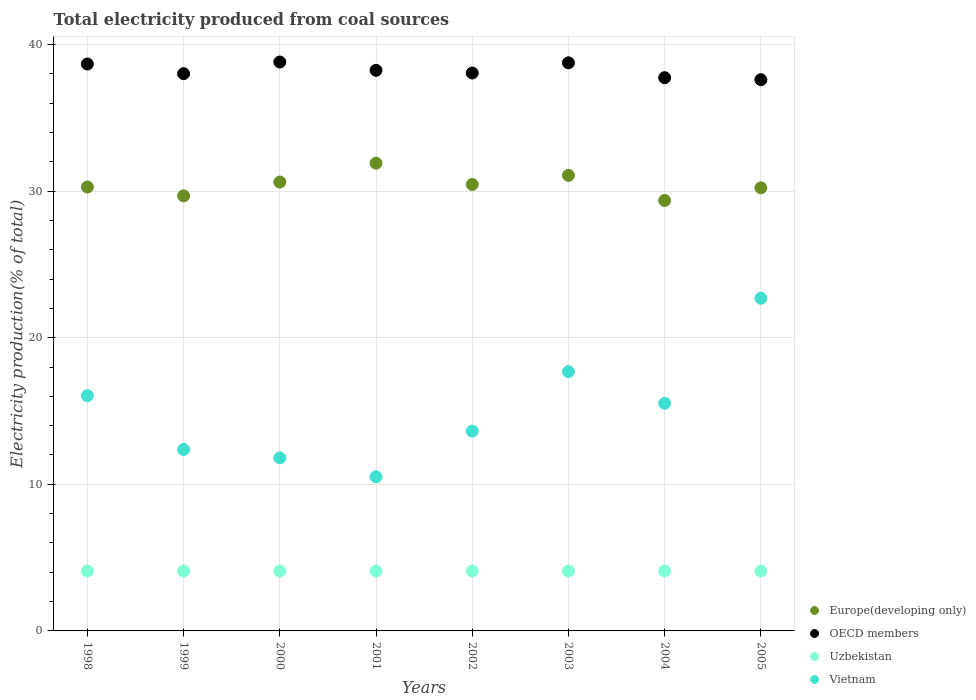What is the total electricity produced in Vietnam in 1999?
Your response must be concise. 12.37. Across all years, what is the maximum total electricity produced in OECD members?
Offer a very short reply. 38.8. Across all years, what is the minimum total electricity produced in Vietnam?
Your answer should be very brief. 10.51. In which year was the total electricity produced in Europe(developing only) maximum?
Your response must be concise. 2001. What is the total total electricity produced in Europe(developing only) in the graph?
Your answer should be compact. 243.56. What is the difference between the total electricity produced in Uzbekistan in 2001 and that in 2003?
Offer a terse response. -0. What is the difference between the total electricity produced in OECD members in 1999 and the total electricity produced in Vietnam in 2000?
Provide a succinct answer. 26.2. What is the average total electricity produced in OECD members per year?
Your answer should be very brief. 38.23. In the year 2000, what is the difference between the total electricity produced in Europe(developing only) and total electricity produced in Vietnam?
Your answer should be very brief. 18.81. In how many years, is the total electricity produced in Uzbekistan greater than 10 %?
Provide a short and direct response. 0. What is the ratio of the total electricity produced in OECD members in 1999 to that in 2003?
Give a very brief answer. 0.98. Is the total electricity produced in Vietnam in 1999 less than that in 2000?
Offer a very short reply. No. Is the difference between the total electricity produced in Europe(developing only) in 1998 and 2005 greater than the difference between the total electricity produced in Vietnam in 1998 and 2005?
Make the answer very short. Yes. What is the difference between the highest and the second highest total electricity produced in Europe(developing only)?
Offer a terse response. 0.83. What is the difference between the highest and the lowest total electricity produced in Uzbekistan?
Offer a very short reply. 0. In how many years, is the total electricity produced in OECD members greater than the average total electricity produced in OECD members taken over all years?
Provide a succinct answer. 4. Is it the case that in every year, the sum of the total electricity produced in OECD members and total electricity produced in Europe(developing only)  is greater than the sum of total electricity produced in Vietnam and total electricity produced in Uzbekistan?
Offer a terse response. Yes. Is it the case that in every year, the sum of the total electricity produced in Vietnam and total electricity produced in OECD members  is greater than the total electricity produced in Europe(developing only)?
Offer a very short reply. Yes. Is the total electricity produced in Europe(developing only) strictly less than the total electricity produced in Uzbekistan over the years?
Keep it short and to the point. No. What is the difference between two consecutive major ticks on the Y-axis?
Provide a short and direct response. 10. Are the values on the major ticks of Y-axis written in scientific E-notation?
Ensure brevity in your answer.  No. Does the graph contain any zero values?
Ensure brevity in your answer.  No. How many legend labels are there?
Ensure brevity in your answer.  4. What is the title of the graph?
Give a very brief answer. Total electricity produced from coal sources. What is the label or title of the X-axis?
Provide a short and direct response. Years. What is the Electricity production(% of total) in Europe(developing only) in 1998?
Your answer should be very brief. 30.28. What is the Electricity production(% of total) in OECD members in 1998?
Keep it short and to the point. 38.66. What is the Electricity production(% of total) of Uzbekistan in 1998?
Offer a terse response. 4.08. What is the Electricity production(% of total) of Vietnam in 1998?
Make the answer very short. 16.05. What is the Electricity production(% of total) of Europe(developing only) in 1999?
Your answer should be compact. 29.67. What is the Electricity production(% of total) of OECD members in 1999?
Provide a succinct answer. 38.01. What is the Electricity production(% of total) in Uzbekistan in 1999?
Provide a succinct answer. 4.09. What is the Electricity production(% of total) in Vietnam in 1999?
Keep it short and to the point. 12.37. What is the Electricity production(% of total) of Europe(developing only) in 2000?
Make the answer very short. 30.61. What is the Electricity production(% of total) of OECD members in 2000?
Your answer should be compact. 38.8. What is the Electricity production(% of total) of Uzbekistan in 2000?
Provide a succinct answer. 4.09. What is the Electricity production(% of total) of Vietnam in 2000?
Offer a very short reply. 11.8. What is the Electricity production(% of total) of Europe(developing only) in 2001?
Keep it short and to the point. 31.9. What is the Electricity production(% of total) of OECD members in 2001?
Your answer should be very brief. 38.23. What is the Electricity production(% of total) of Uzbekistan in 2001?
Offer a very short reply. 4.08. What is the Electricity production(% of total) in Vietnam in 2001?
Ensure brevity in your answer.  10.51. What is the Electricity production(% of total) of Europe(developing only) in 2002?
Your answer should be very brief. 30.45. What is the Electricity production(% of total) of OECD members in 2002?
Give a very brief answer. 38.05. What is the Electricity production(% of total) of Uzbekistan in 2002?
Offer a very short reply. 4.08. What is the Electricity production(% of total) in Vietnam in 2002?
Your answer should be compact. 13.63. What is the Electricity production(% of total) in Europe(developing only) in 2003?
Give a very brief answer. 31.07. What is the Electricity production(% of total) in OECD members in 2003?
Offer a very short reply. 38.75. What is the Electricity production(% of total) of Uzbekistan in 2003?
Your response must be concise. 4.09. What is the Electricity production(% of total) in Vietnam in 2003?
Offer a very short reply. 17.68. What is the Electricity production(% of total) of Europe(developing only) in 2004?
Offer a very short reply. 29.36. What is the Electricity production(% of total) of OECD members in 2004?
Make the answer very short. 37.73. What is the Electricity production(% of total) of Uzbekistan in 2004?
Your answer should be very brief. 4.09. What is the Electricity production(% of total) of Vietnam in 2004?
Your answer should be compact. 15.52. What is the Electricity production(% of total) of Europe(developing only) in 2005?
Your answer should be compact. 30.22. What is the Electricity production(% of total) of OECD members in 2005?
Provide a short and direct response. 37.6. What is the Electricity production(% of total) of Uzbekistan in 2005?
Your answer should be compact. 4.08. What is the Electricity production(% of total) in Vietnam in 2005?
Give a very brief answer. 22.69. Across all years, what is the maximum Electricity production(% of total) of Europe(developing only)?
Provide a succinct answer. 31.9. Across all years, what is the maximum Electricity production(% of total) of OECD members?
Give a very brief answer. 38.8. Across all years, what is the maximum Electricity production(% of total) in Uzbekistan?
Your answer should be compact. 4.09. Across all years, what is the maximum Electricity production(% of total) of Vietnam?
Your answer should be very brief. 22.69. Across all years, what is the minimum Electricity production(% of total) in Europe(developing only)?
Keep it short and to the point. 29.36. Across all years, what is the minimum Electricity production(% of total) of OECD members?
Give a very brief answer. 37.6. Across all years, what is the minimum Electricity production(% of total) of Uzbekistan?
Provide a succinct answer. 4.08. Across all years, what is the minimum Electricity production(% of total) of Vietnam?
Your answer should be compact. 10.51. What is the total Electricity production(% of total) in Europe(developing only) in the graph?
Your response must be concise. 243.56. What is the total Electricity production(% of total) of OECD members in the graph?
Provide a succinct answer. 305.83. What is the total Electricity production(% of total) in Uzbekistan in the graph?
Ensure brevity in your answer.  32.68. What is the total Electricity production(% of total) of Vietnam in the graph?
Ensure brevity in your answer.  120.26. What is the difference between the Electricity production(% of total) of Europe(developing only) in 1998 and that in 1999?
Give a very brief answer. 0.61. What is the difference between the Electricity production(% of total) in OECD members in 1998 and that in 1999?
Provide a succinct answer. 0.66. What is the difference between the Electricity production(% of total) of Uzbekistan in 1998 and that in 1999?
Your answer should be very brief. -0. What is the difference between the Electricity production(% of total) of Vietnam in 1998 and that in 1999?
Your response must be concise. 3.67. What is the difference between the Electricity production(% of total) of Europe(developing only) in 1998 and that in 2000?
Provide a succinct answer. -0.34. What is the difference between the Electricity production(% of total) in OECD members in 1998 and that in 2000?
Provide a short and direct response. -0.14. What is the difference between the Electricity production(% of total) of Uzbekistan in 1998 and that in 2000?
Make the answer very short. -0. What is the difference between the Electricity production(% of total) of Vietnam in 1998 and that in 2000?
Your answer should be compact. 4.24. What is the difference between the Electricity production(% of total) in Europe(developing only) in 1998 and that in 2001?
Provide a short and direct response. -1.63. What is the difference between the Electricity production(% of total) in OECD members in 1998 and that in 2001?
Make the answer very short. 0.43. What is the difference between the Electricity production(% of total) in Uzbekistan in 1998 and that in 2001?
Provide a succinct answer. 0. What is the difference between the Electricity production(% of total) in Vietnam in 1998 and that in 2001?
Offer a terse response. 5.53. What is the difference between the Electricity production(% of total) of Europe(developing only) in 1998 and that in 2002?
Keep it short and to the point. -0.17. What is the difference between the Electricity production(% of total) in OECD members in 1998 and that in 2002?
Your answer should be compact. 0.61. What is the difference between the Electricity production(% of total) of Uzbekistan in 1998 and that in 2002?
Your answer should be compact. 0. What is the difference between the Electricity production(% of total) of Vietnam in 1998 and that in 2002?
Provide a short and direct response. 2.42. What is the difference between the Electricity production(% of total) in Europe(developing only) in 1998 and that in 2003?
Keep it short and to the point. -0.8. What is the difference between the Electricity production(% of total) in OECD members in 1998 and that in 2003?
Ensure brevity in your answer.  -0.08. What is the difference between the Electricity production(% of total) in Uzbekistan in 1998 and that in 2003?
Give a very brief answer. -0. What is the difference between the Electricity production(% of total) in Vietnam in 1998 and that in 2003?
Offer a terse response. -1.64. What is the difference between the Electricity production(% of total) in Europe(developing only) in 1998 and that in 2004?
Your answer should be very brief. 0.92. What is the difference between the Electricity production(% of total) in OECD members in 1998 and that in 2004?
Your answer should be compact. 0.93. What is the difference between the Electricity production(% of total) of Uzbekistan in 1998 and that in 2004?
Provide a short and direct response. -0. What is the difference between the Electricity production(% of total) in Vietnam in 1998 and that in 2004?
Provide a short and direct response. 0.52. What is the difference between the Electricity production(% of total) of Europe(developing only) in 1998 and that in 2005?
Keep it short and to the point. 0.06. What is the difference between the Electricity production(% of total) in OECD members in 1998 and that in 2005?
Make the answer very short. 1.07. What is the difference between the Electricity production(% of total) of Uzbekistan in 1998 and that in 2005?
Your answer should be compact. 0. What is the difference between the Electricity production(% of total) of Vietnam in 1998 and that in 2005?
Your answer should be compact. -6.65. What is the difference between the Electricity production(% of total) of Europe(developing only) in 1999 and that in 2000?
Your answer should be compact. -0.94. What is the difference between the Electricity production(% of total) in OECD members in 1999 and that in 2000?
Offer a terse response. -0.79. What is the difference between the Electricity production(% of total) of Uzbekistan in 1999 and that in 2000?
Offer a very short reply. -0. What is the difference between the Electricity production(% of total) of Vietnam in 1999 and that in 2000?
Give a very brief answer. 0.57. What is the difference between the Electricity production(% of total) of Europe(developing only) in 1999 and that in 2001?
Your answer should be very brief. -2.23. What is the difference between the Electricity production(% of total) of OECD members in 1999 and that in 2001?
Make the answer very short. -0.23. What is the difference between the Electricity production(% of total) in Uzbekistan in 1999 and that in 2001?
Provide a succinct answer. 0. What is the difference between the Electricity production(% of total) in Vietnam in 1999 and that in 2001?
Keep it short and to the point. 1.86. What is the difference between the Electricity production(% of total) of Europe(developing only) in 1999 and that in 2002?
Provide a succinct answer. -0.78. What is the difference between the Electricity production(% of total) in OECD members in 1999 and that in 2002?
Your answer should be compact. -0.04. What is the difference between the Electricity production(% of total) of Uzbekistan in 1999 and that in 2002?
Ensure brevity in your answer.  0. What is the difference between the Electricity production(% of total) of Vietnam in 1999 and that in 2002?
Offer a terse response. -1.25. What is the difference between the Electricity production(% of total) of Europe(developing only) in 1999 and that in 2003?
Keep it short and to the point. -1.4. What is the difference between the Electricity production(% of total) of OECD members in 1999 and that in 2003?
Your answer should be compact. -0.74. What is the difference between the Electricity production(% of total) of Uzbekistan in 1999 and that in 2003?
Make the answer very short. 0. What is the difference between the Electricity production(% of total) of Vietnam in 1999 and that in 2003?
Make the answer very short. -5.31. What is the difference between the Electricity production(% of total) of Europe(developing only) in 1999 and that in 2004?
Give a very brief answer. 0.31. What is the difference between the Electricity production(% of total) of OECD members in 1999 and that in 2004?
Your response must be concise. 0.28. What is the difference between the Electricity production(% of total) in Uzbekistan in 1999 and that in 2004?
Your answer should be compact. 0. What is the difference between the Electricity production(% of total) in Vietnam in 1999 and that in 2004?
Your answer should be compact. -3.15. What is the difference between the Electricity production(% of total) in Europe(developing only) in 1999 and that in 2005?
Your response must be concise. -0.55. What is the difference between the Electricity production(% of total) of OECD members in 1999 and that in 2005?
Provide a short and direct response. 0.41. What is the difference between the Electricity production(% of total) in Uzbekistan in 1999 and that in 2005?
Provide a short and direct response. 0. What is the difference between the Electricity production(% of total) of Vietnam in 1999 and that in 2005?
Your response must be concise. -10.32. What is the difference between the Electricity production(% of total) of Europe(developing only) in 2000 and that in 2001?
Your answer should be very brief. -1.29. What is the difference between the Electricity production(% of total) of OECD members in 2000 and that in 2001?
Make the answer very short. 0.56. What is the difference between the Electricity production(% of total) in Uzbekistan in 2000 and that in 2001?
Provide a succinct answer. 0. What is the difference between the Electricity production(% of total) of Vietnam in 2000 and that in 2001?
Provide a short and direct response. 1.29. What is the difference between the Electricity production(% of total) in Europe(developing only) in 2000 and that in 2002?
Your answer should be compact. 0.16. What is the difference between the Electricity production(% of total) of OECD members in 2000 and that in 2002?
Provide a short and direct response. 0.75. What is the difference between the Electricity production(% of total) of Uzbekistan in 2000 and that in 2002?
Keep it short and to the point. 0. What is the difference between the Electricity production(% of total) of Vietnam in 2000 and that in 2002?
Your answer should be compact. -1.82. What is the difference between the Electricity production(% of total) in Europe(developing only) in 2000 and that in 2003?
Keep it short and to the point. -0.46. What is the difference between the Electricity production(% of total) in OECD members in 2000 and that in 2003?
Your response must be concise. 0.05. What is the difference between the Electricity production(% of total) in Uzbekistan in 2000 and that in 2003?
Provide a succinct answer. 0. What is the difference between the Electricity production(% of total) of Vietnam in 2000 and that in 2003?
Make the answer very short. -5.88. What is the difference between the Electricity production(% of total) of Europe(developing only) in 2000 and that in 2004?
Offer a very short reply. 1.25. What is the difference between the Electricity production(% of total) in OECD members in 2000 and that in 2004?
Offer a terse response. 1.07. What is the difference between the Electricity production(% of total) of Uzbekistan in 2000 and that in 2004?
Your answer should be compact. 0. What is the difference between the Electricity production(% of total) in Vietnam in 2000 and that in 2004?
Give a very brief answer. -3.72. What is the difference between the Electricity production(% of total) of Europe(developing only) in 2000 and that in 2005?
Your response must be concise. 0.39. What is the difference between the Electricity production(% of total) of OECD members in 2000 and that in 2005?
Your response must be concise. 1.2. What is the difference between the Electricity production(% of total) of Uzbekistan in 2000 and that in 2005?
Your answer should be very brief. 0. What is the difference between the Electricity production(% of total) in Vietnam in 2000 and that in 2005?
Make the answer very short. -10.89. What is the difference between the Electricity production(% of total) in Europe(developing only) in 2001 and that in 2002?
Your answer should be compact. 1.45. What is the difference between the Electricity production(% of total) in OECD members in 2001 and that in 2002?
Your answer should be very brief. 0.18. What is the difference between the Electricity production(% of total) of Uzbekistan in 2001 and that in 2002?
Your answer should be compact. -0. What is the difference between the Electricity production(% of total) in Vietnam in 2001 and that in 2002?
Give a very brief answer. -3.11. What is the difference between the Electricity production(% of total) of Europe(developing only) in 2001 and that in 2003?
Offer a terse response. 0.83. What is the difference between the Electricity production(% of total) of OECD members in 2001 and that in 2003?
Provide a short and direct response. -0.51. What is the difference between the Electricity production(% of total) of Uzbekistan in 2001 and that in 2003?
Keep it short and to the point. -0. What is the difference between the Electricity production(% of total) in Vietnam in 2001 and that in 2003?
Give a very brief answer. -7.17. What is the difference between the Electricity production(% of total) of Europe(developing only) in 2001 and that in 2004?
Keep it short and to the point. 2.54. What is the difference between the Electricity production(% of total) of OECD members in 2001 and that in 2004?
Your answer should be very brief. 0.5. What is the difference between the Electricity production(% of total) in Uzbekistan in 2001 and that in 2004?
Provide a succinct answer. -0. What is the difference between the Electricity production(% of total) of Vietnam in 2001 and that in 2004?
Ensure brevity in your answer.  -5.01. What is the difference between the Electricity production(% of total) of Europe(developing only) in 2001 and that in 2005?
Your response must be concise. 1.68. What is the difference between the Electricity production(% of total) in OECD members in 2001 and that in 2005?
Offer a very short reply. 0.64. What is the difference between the Electricity production(% of total) of Uzbekistan in 2001 and that in 2005?
Your response must be concise. 0. What is the difference between the Electricity production(% of total) in Vietnam in 2001 and that in 2005?
Offer a terse response. -12.18. What is the difference between the Electricity production(% of total) in Europe(developing only) in 2002 and that in 2003?
Make the answer very short. -0.62. What is the difference between the Electricity production(% of total) in OECD members in 2002 and that in 2003?
Make the answer very short. -0.7. What is the difference between the Electricity production(% of total) of Uzbekistan in 2002 and that in 2003?
Your response must be concise. -0. What is the difference between the Electricity production(% of total) of Vietnam in 2002 and that in 2003?
Your answer should be compact. -4.06. What is the difference between the Electricity production(% of total) in Europe(developing only) in 2002 and that in 2004?
Give a very brief answer. 1.09. What is the difference between the Electricity production(% of total) in OECD members in 2002 and that in 2004?
Ensure brevity in your answer.  0.32. What is the difference between the Electricity production(% of total) of Uzbekistan in 2002 and that in 2004?
Ensure brevity in your answer.  -0. What is the difference between the Electricity production(% of total) in Vietnam in 2002 and that in 2004?
Ensure brevity in your answer.  -1.9. What is the difference between the Electricity production(% of total) of Europe(developing only) in 2002 and that in 2005?
Give a very brief answer. 0.23. What is the difference between the Electricity production(% of total) in OECD members in 2002 and that in 2005?
Your response must be concise. 0.45. What is the difference between the Electricity production(% of total) of Uzbekistan in 2002 and that in 2005?
Your response must be concise. 0. What is the difference between the Electricity production(% of total) in Vietnam in 2002 and that in 2005?
Make the answer very short. -9.06. What is the difference between the Electricity production(% of total) in Europe(developing only) in 2003 and that in 2004?
Make the answer very short. 1.71. What is the difference between the Electricity production(% of total) of OECD members in 2003 and that in 2004?
Your answer should be compact. 1.02. What is the difference between the Electricity production(% of total) of Uzbekistan in 2003 and that in 2004?
Your answer should be compact. -0. What is the difference between the Electricity production(% of total) of Vietnam in 2003 and that in 2004?
Provide a succinct answer. 2.16. What is the difference between the Electricity production(% of total) of Europe(developing only) in 2003 and that in 2005?
Ensure brevity in your answer.  0.85. What is the difference between the Electricity production(% of total) of OECD members in 2003 and that in 2005?
Provide a short and direct response. 1.15. What is the difference between the Electricity production(% of total) in Uzbekistan in 2003 and that in 2005?
Provide a succinct answer. 0. What is the difference between the Electricity production(% of total) in Vietnam in 2003 and that in 2005?
Give a very brief answer. -5.01. What is the difference between the Electricity production(% of total) of Europe(developing only) in 2004 and that in 2005?
Provide a short and direct response. -0.86. What is the difference between the Electricity production(% of total) of OECD members in 2004 and that in 2005?
Your response must be concise. 0.13. What is the difference between the Electricity production(% of total) in Uzbekistan in 2004 and that in 2005?
Ensure brevity in your answer.  0. What is the difference between the Electricity production(% of total) of Vietnam in 2004 and that in 2005?
Offer a very short reply. -7.17. What is the difference between the Electricity production(% of total) of Europe(developing only) in 1998 and the Electricity production(% of total) of OECD members in 1999?
Your answer should be compact. -7.73. What is the difference between the Electricity production(% of total) in Europe(developing only) in 1998 and the Electricity production(% of total) in Uzbekistan in 1999?
Make the answer very short. 26.19. What is the difference between the Electricity production(% of total) of Europe(developing only) in 1998 and the Electricity production(% of total) of Vietnam in 1999?
Your response must be concise. 17.9. What is the difference between the Electricity production(% of total) in OECD members in 1998 and the Electricity production(% of total) in Uzbekistan in 1999?
Your answer should be compact. 34.58. What is the difference between the Electricity production(% of total) of OECD members in 1998 and the Electricity production(% of total) of Vietnam in 1999?
Ensure brevity in your answer.  26.29. What is the difference between the Electricity production(% of total) of Uzbekistan in 1998 and the Electricity production(% of total) of Vietnam in 1999?
Give a very brief answer. -8.29. What is the difference between the Electricity production(% of total) in Europe(developing only) in 1998 and the Electricity production(% of total) in OECD members in 2000?
Provide a short and direct response. -8.52. What is the difference between the Electricity production(% of total) in Europe(developing only) in 1998 and the Electricity production(% of total) in Uzbekistan in 2000?
Offer a terse response. 26.19. What is the difference between the Electricity production(% of total) of Europe(developing only) in 1998 and the Electricity production(% of total) of Vietnam in 2000?
Make the answer very short. 18.47. What is the difference between the Electricity production(% of total) of OECD members in 1998 and the Electricity production(% of total) of Uzbekistan in 2000?
Your response must be concise. 34.58. What is the difference between the Electricity production(% of total) in OECD members in 1998 and the Electricity production(% of total) in Vietnam in 2000?
Offer a very short reply. 26.86. What is the difference between the Electricity production(% of total) in Uzbekistan in 1998 and the Electricity production(% of total) in Vietnam in 2000?
Offer a terse response. -7.72. What is the difference between the Electricity production(% of total) in Europe(developing only) in 1998 and the Electricity production(% of total) in OECD members in 2001?
Offer a very short reply. -7.96. What is the difference between the Electricity production(% of total) of Europe(developing only) in 1998 and the Electricity production(% of total) of Uzbekistan in 2001?
Give a very brief answer. 26.19. What is the difference between the Electricity production(% of total) in Europe(developing only) in 1998 and the Electricity production(% of total) in Vietnam in 2001?
Give a very brief answer. 19.76. What is the difference between the Electricity production(% of total) of OECD members in 1998 and the Electricity production(% of total) of Uzbekistan in 2001?
Ensure brevity in your answer.  34.58. What is the difference between the Electricity production(% of total) of OECD members in 1998 and the Electricity production(% of total) of Vietnam in 2001?
Ensure brevity in your answer.  28.15. What is the difference between the Electricity production(% of total) in Uzbekistan in 1998 and the Electricity production(% of total) in Vietnam in 2001?
Provide a short and direct response. -6.43. What is the difference between the Electricity production(% of total) of Europe(developing only) in 1998 and the Electricity production(% of total) of OECD members in 2002?
Provide a succinct answer. -7.77. What is the difference between the Electricity production(% of total) of Europe(developing only) in 1998 and the Electricity production(% of total) of Uzbekistan in 2002?
Ensure brevity in your answer.  26.19. What is the difference between the Electricity production(% of total) in Europe(developing only) in 1998 and the Electricity production(% of total) in Vietnam in 2002?
Make the answer very short. 16.65. What is the difference between the Electricity production(% of total) of OECD members in 1998 and the Electricity production(% of total) of Uzbekistan in 2002?
Provide a succinct answer. 34.58. What is the difference between the Electricity production(% of total) in OECD members in 1998 and the Electricity production(% of total) in Vietnam in 2002?
Give a very brief answer. 25.04. What is the difference between the Electricity production(% of total) in Uzbekistan in 1998 and the Electricity production(% of total) in Vietnam in 2002?
Provide a succinct answer. -9.54. What is the difference between the Electricity production(% of total) in Europe(developing only) in 1998 and the Electricity production(% of total) in OECD members in 2003?
Offer a terse response. -8.47. What is the difference between the Electricity production(% of total) of Europe(developing only) in 1998 and the Electricity production(% of total) of Uzbekistan in 2003?
Provide a short and direct response. 26.19. What is the difference between the Electricity production(% of total) in Europe(developing only) in 1998 and the Electricity production(% of total) in Vietnam in 2003?
Provide a short and direct response. 12.59. What is the difference between the Electricity production(% of total) in OECD members in 1998 and the Electricity production(% of total) in Uzbekistan in 2003?
Your answer should be very brief. 34.58. What is the difference between the Electricity production(% of total) in OECD members in 1998 and the Electricity production(% of total) in Vietnam in 2003?
Your response must be concise. 20.98. What is the difference between the Electricity production(% of total) in Uzbekistan in 1998 and the Electricity production(% of total) in Vietnam in 2003?
Offer a very short reply. -13.6. What is the difference between the Electricity production(% of total) of Europe(developing only) in 1998 and the Electricity production(% of total) of OECD members in 2004?
Provide a short and direct response. -7.45. What is the difference between the Electricity production(% of total) in Europe(developing only) in 1998 and the Electricity production(% of total) in Uzbekistan in 2004?
Keep it short and to the point. 26.19. What is the difference between the Electricity production(% of total) of Europe(developing only) in 1998 and the Electricity production(% of total) of Vietnam in 2004?
Your response must be concise. 14.75. What is the difference between the Electricity production(% of total) of OECD members in 1998 and the Electricity production(% of total) of Uzbekistan in 2004?
Offer a very short reply. 34.58. What is the difference between the Electricity production(% of total) of OECD members in 1998 and the Electricity production(% of total) of Vietnam in 2004?
Make the answer very short. 23.14. What is the difference between the Electricity production(% of total) of Uzbekistan in 1998 and the Electricity production(% of total) of Vietnam in 2004?
Offer a terse response. -11.44. What is the difference between the Electricity production(% of total) of Europe(developing only) in 1998 and the Electricity production(% of total) of OECD members in 2005?
Provide a succinct answer. -7.32. What is the difference between the Electricity production(% of total) in Europe(developing only) in 1998 and the Electricity production(% of total) in Uzbekistan in 2005?
Your response must be concise. 26.19. What is the difference between the Electricity production(% of total) of Europe(developing only) in 1998 and the Electricity production(% of total) of Vietnam in 2005?
Your answer should be very brief. 7.58. What is the difference between the Electricity production(% of total) in OECD members in 1998 and the Electricity production(% of total) in Uzbekistan in 2005?
Offer a terse response. 34.58. What is the difference between the Electricity production(% of total) in OECD members in 1998 and the Electricity production(% of total) in Vietnam in 2005?
Your response must be concise. 15.97. What is the difference between the Electricity production(% of total) in Uzbekistan in 1998 and the Electricity production(% of total) in Vietnam in 2005?
Your answer should be very brief. -18.61. What is the difference between the Electricity production(% of total) of Europe(developing only) in 1999 and the Electricity production(% of total) of OECD members in 2000?
Offer a terse response. -9.13. What is the difference between the Electricity production(% of total) of Europe(developing only) in 1999 and the Electricity production(% of total) of Uzbekistan in 2000?
Ensure brevity in your answer.  25.58. What is the difference between the Electricity production(% of total) of Europe(developing only) in 1999 and the Electricity production(% of total) of Vietnam in 2000?
Offer a very short reply. 17.87. What is the difference between the Electricity production(% of total) of OECD members in 1999 and the Electricity production(% of total) of Uzbekistan in 2000?
Offer a very short reply. 33.92. What is the difference between the Electricity production(% of total) in OECD members in 1999 and the Electricity production(% of total) in Vietnam in 2000?
Your answer should be compact. 26.2. What is the difference between the Electricity production(% of total) in Uzbekistan in 1999 and the Electricity production(% of total) in Vietnam in 2000?
Give a very brief answer. -7.72. What is the difference between the Electricity production(% of total) of Europe(developing only) in 1999 and the Electricity production(% of total) of OECD members in 2001?
Provide a short and direct response. -8.56. What is the difference between the Electricity production(% of total) of Europe(developing only) in 1999 and the Electricity production(% of total) of Uzbekistan in 2001?
Ensure brevity in your answer.  25.59. What is the difference between the Electricity production(% of total) in Europe(developing only) in 1999 and the Electricity production(% of total) in Vietnam in 2001?
Your response must be concise. 19.16. What is the difference between the Electricity production(% of total) in OECD members in 1999 and the Electricity production(% of total) in Uzbekistan in 2001?
Keep it short and to the point. 33.92. What is the difference between the Electricity production(% of total) in OECD members in 1999 and the Electricity production(% of total) in Vietnam in 2001?
Your response must be concise. 27.49. What is the difference between the Electricity production(% of total) of Uzbekistan in 1999 and the Electricity production(% of total) of Vietnam in 2001?
Make the answer very short. -6.43. What is the difference between the Electricity production(% of total) of Europe(developing only) in 1999 and the Electricity production(% of total) of OECD members in 2002?
Provide a succinct answer. -8.38. What is the difference between the Electricity production(% of total) in Europe(developing only) in 1999 and the Electricity production(% of total) in Uzbekistan in 2002?
Offer a terse response. 25.59. What is the difference between the Electricity production(% of total) of Europe(developing only) in 1999 and the Electricity production(% of total) of Vietnam in 2002?
Offer a terse response. 16.04. What is the difference between the Electricity production(% of total) in OECD members in 1999 and the Electricity production(% of total) in Uzbekistan in 2002?
Provide a succinct answer. 33.92. What is the difference between the Electricity production(% of total) in OECD members in 1999 and the Electricity production(% of total) in Vietnam in 2002?
Your answer should be compact. 24.38. What is the difference between the Electricity production(% of total) of Uzbekistan in 1999 and the Electricity production(% of total) of Vietnam in 2002?
Make the answer very short. -9.54. What is the difference between the Electricity production(% of total) in Europe(developing only) in 1999 and the Electricity production(% of total) in OECD members in 2003?
Keep it short and to the point. -9.08. What is the difference between the Electricity production(% of total) of Europe(developing only) in 1999 and the Electricity production(% of total) of Uzbekistan in 2003?
Offer a very short reply. 25.59. What is the difference between the Electricity production(% of total) of Europe(developing only) in 1999 and the Electricity production(% of total) of Vietnam in 2003?
Offer a terse response. 11.99. What is the difference between the Electricity production(% of total) in OECD members in 1999 and the Electricity production(% of total) in Uzbekistan in 2003?
Provide a succinct answer. 33.92. What is the difference between the Electricity production(% of total) in OECD members in 1999 and the Electricity production(% of total) in Vietnam in 2003?
Keep it short and to the point. 20.32. What is the difference between the Electricity production(% of total) of Uzbekistan in 1999 and the Electricity production(% of total) of Vietnam in 2003?
Your response must be concise. -13.6. What is the difference between the Electricity production(% of total) of Europe(developing only) in 1999 and the Electricity production(% of total) of OECD members in 2004?
Offer a terse response. -8.06. What is the difference between the Electricity production(% of total) of Europe(developing only) in 1999 and the Electricity production(% of total) of Uzbekistan in 2004?
Offer a very short reply. 25.58. What is the difference between the Electricity production(% of total) of Europe(developing only) in 1999 and the Electricity production(% of total) of Vietnam in 2004?
Keep it short and to the point. 14.15. What is the difference between the Electricity production(% of total) of OECD members in 1999 and the Electricity production(% of total) of Uzbekistan in 2004?
Make the answer very short. 33.92. What is the difference between the Electricity production(% of total) in OECD members in 1999 and the Electricity production(% of total) in Vietnam in 2004?
Provide a succinct answer. 22.48. What is the difference between the Electricity production(% of total) in Uzbekistan in 1999 and the Electricity production(% of total) in Vietnam in 2004?
Provide a short and direct response. -11.44. What is the difference between the Electricity production(% of total) of Europe(developing only) in 1999 and the Electricity production(% of total) of OECD members in 2005?
Offer a terse response. -7.93. What is the difference between the Electricity production(% of total) in Europe(developing only) in 1999 and the Electricity production(% of total) in Uzbekistan in 2005?
Make the answer very short. 25.59. What is the difference between the Electricity production(% of total) in Europe(developing only) in 1999 and the Electricity production(% of total) in Vietnam in 2005?
Give a very brief answer. 6.98. What is the difference between the Electricity production(% of total) of OECD members in 1999 and the Electricity production(% of total) of Uzbekistan in 2005?
Your answer should be compact. 33.92. What is the difference between the Electricity production(% of total) of OECD members in 1999 and the Electricity production(% of total) of Vietnam in 2005?
Ensure brevity in your answer.  15.32. What is the difference between the Electricity production(% of total) of Uzbekistan in 1999 and the Electricity production(% of total) of Vietnam in 2005?
Provide a short and direct response. -18.6. What is the difference between the Electricity production(% of total) of Europe(developing only) in 2000 and the Electricity production(% of total) of OECD members in 2001?
Your answer should be very brief. -7.62. What is the difference between the Electricity production(% of total) in Europe(developing only) in 2000 and the Electricity production(% of total) in Uzbekistan in 2001?
Your answer should be very brief. 26.53. What is the difference between the Electricity production(% of total) of Europe(developing only) in 2000 and the Electricity production(% of total) of Vietnam in 2001?
Ensure brevity in your answer.  20.1. What is the difference between the Electricity production(% of total) of OECD members in 2000 and the Electricity production(% of total) of Uzbekistan in 2001?
Offer a very short reply. 34.72. What is the difference between the Electricity production(% of total) in OECD members in 2000 and the Electricity production(% of total) in Vietnam in 2001?
Your answer should be compact. 28.29. What is the difference between the Electricity production(% of total) of Uzbekistan in 2000 and the Electricity production(% of total) of Vietnam in 2001?
Give a very brief answer. -6.43. What is the difference between the Electricity production(% of total) in Europe(developing only) in 2000 and the Electricity production(% of total) in OECD members in 2002?
Offer a very short reply. -7.44. What is the difference between the Electricity production(% of total) of Europe(developing only) in 2000 and the Electricity production(% of total) of Uzbekistan in 2002?
Keep it short and to the point. 26.53. What is the difference between the Electricity production(% of total) of Europe(developing only) in 2000 and the Electricity production(% of total) of Vietnam in 2002?
Your response must be concise. 16.99. What is the difference between the Electricity production(% of total) in OECD members in 2000 and the Electricity production(% of total) in Uzbekistan in 2002?
Provide a succinct answer. 34.72. What is the difference between the Electricity production(% of total) in OECD members in 2000 and the Electricity production(% of total) in Vietnam in 2002?
Provide a short and direct response. 25.17. What is the difference between the Electricity production(% of total) in Uzbekistan in 2000 and the Electricity production(% of total) in Vietnam in 2002?
Your response must be concise. -9.54. What is the difference between the Electricity production(% of total) of Europe(developing only) in 2000 and the Electricity production(% of total) of OECD members in 2003?
Your answer should be very brief. -8.13. What is the difference between the Electricity production(% of total) of Europe(developing only) in 2000 and the Electricity production(% of total) of Uzbekistan in 2003?
Your response must be concise. 26.53. What is the difference between the Electricity production(% of total) of Europe(developing only) in 2000 and the Electricity production(% of total) of Vietnam in 2003?
Provide a succinct answer. 12.93. What is the difference between the Electricity production(% of total) in OECD members in 2000 and the Electricity production(% of total) in Uzbekistan in 2003?
Your answer should be very brief. 34.72. What is the difference between the Electricity production(% of total) of OECD members in 2000 and the Electricity production(% of total) of Vietnam in 2003?
Provide a succinct answer. 21.12. What is the difference between the Electricity production(% of total) in Uzbekistan in 2000 and the Electricity production(% of total) in Vietnam in 2003?
Offer a very short reply. -13.6. What is the difference between the Electricity production(% of total) in Europe(developing only) in 2000 and the Electricity production(% of total) in OECD members in 2004?
Provide a succinct answer. -7.12. What is the difference between the Electricity production(% of total) of Europe(developing only) in 2000 and the Electricity production(% of total) of Uzbekistan in 2004?
Your answer should be very brief. 26.53. What is the difference between the Electricity production(% of total) in Europe(developing only) in 2000 and the Electricity production(% of total) in Vietnam in 2004?
Give a very brief answer. 15.09. What is the difference between the Electricity production(% of total) in OECD members in 2000 and the Electricity production(% of total) in Uzbekistan in 2004?
Give a very brief answer. 34.71. What is the difference between the Electricity production(% of total) of OECD members in 2000 and the Electricity production(% of total) of Vietnam in 2004?
Give a very brief answer. 23.28. What is the difference between the Electricity production(% of total) in Uzbekistan in 2000 and the Electricity production(% of total) in Vietnam in 2004?
Your response must be concise. -11.44. What is the difference between the Electricity production(% of total) of Europe(developing only) in 2000 and the Electricity production(% of total) of OECD members in 2005?
Make the answer very short. -6.98. What is the difference between the Electricity production(% of total) in Europe(developing only) in 2000 and the Electricity production(% of total) in Uzbekistan in 2005?
Ensure brevity in your answer.  26.53. What is the difference between the Electricity production(% of total) in Europe(developing only) in 2000 and the Electricity production(% of total) in Vietnam in 2005?
Offer a very short reply. 7.92. What is the difference between the Electricity production(% of total) in OECD members in 2000 and the Electricity production(% of total) in Uzbekistan in 2005?
Ensure brevity in your answer.  34.72. What is the difference between the Electricity production(% of total) in OECD members in 2000 and the Electricity production(% of total) in Vietnam in 2005?
Give a very brief answer. 16.11. What is the difference between the Electricity production(% of total) in Uzbekistan in 2000 and the Electricity production(% of total) in Vietnam in 2005?
Provide a short and direct response. -18.6. What is the difference between the Electricity production(% of total) of Europe(developing only) in 2001 and the Electricity production(% of total) of OECD members in 2002?
Give a very brief answer. -6.15. What is the difference between the Electricity production(% of total) of Europe(developing only) in 2001 and the Electricity production(% of total) of Uzbekistan in 2002?
Provide a succinct answer. 27.82. What is the difference between the Electricity production(% of total) of Europe(developing only) in 2001 and the Electricity production(% of total) of Vietnam in 2002?
Make the answer very short. 18.28. What is the difference between the Electricity production(% of total) of OECD members in 2001 and the Electricity production(% of total) of Uzbekistan in 2002?
Give a very brief answer. 34.15. What is the difference between the Electricity production(% of total) of OECD members in 2001 and the Electricity production(% of total) of Vietnam in 2002?
Offer a terse response. 24.61. What is the difference between the Electricity production(% of total) of Uzbekistan in 2001 and the Electricity production(% of total) of Vietnam in 2002?
Make the answer very short. -9.54. What is the difference between the Electricity production(% of total) of Europe(developing only) in 2001 and the Electricity production(% of total) of OECD members in 2003?
Make the answer very short. -6.84. What is the difference between the Electricity production(% of total) in Europe(developing only) in 2001 and the Electricity production(% of total) in Uzbekistan in 2003?
Your answer should be very brief. 27.82. What is the difference between the Electricity production(% of total) in Europe(developing only) in 2001 and the Electricity production(% of total) in Vietnam in 2003?
Ensure brevity in your answer.  14.22. What is the difference between the Electricity production(% of total) in OECD members in 2001 and the Electricity production(% of total) in Uzbekistan in 2003?
Offer a very short reply. 34.15. What is the difference between the Electricity production(% of total) in OECD members in 2001 and the Electricity production(% of total) in Vietnam in 2003?
Give a very brief answer. 20.55. What is the difference between the Electricity production(% of total) of Uzbekistan in 2001 and the Electricity production(% of total) of Vietnam in 2003?
Your response must be concise. -13.6. What is the difference between the Electricity production(% of total) in Europe(developing only) in 2001 and the Electricity production(% of total) in OECD members in 2004?
Provide a short and direct response. -5.83. What is the difference between the Electricity production(% of total) in Europe(developing only) in 2001 and the Electricity production(% of total) in Uzbekistan in 2004?
Ensure brevity in your answer.  27.82. What is the difference between the Electricity production(% of total) in Europe(developing only) in 2001 and the Electricity production(% of total) in Vietnam in 2004?
Provide a succinct answer. 16.38. What is the difference between the Electricity production(% of total) in OECD members in 2001 and the Electricity production(% of total) in Uzbekistan in 2004?
Offer a very short reply. 34.15. What is the difference between the Electricity production(% of total) of OECD members in 2001 and the Electricity production(% of total) of Vietnam in 2004?
Provide a succinct answer. 22.71. What is the difference between the Electricity production(% of total) in Uzbekistan in 2001 and the Electricity production(% of total) in Vietnam in 2004?
Provide a succinct answer. -11.44. What is the difference between the Electricity production(% of total) of Europe(developing only) in 2001 and the Electricity production(% of total) of OECD members in 2005?
Your answer should be compact. -5.69. What is the difference between the Electricity production(% of total) in Europe(developing only) in 2001 and the Electricity production(% of total) in Uzbekistan in 2005?
Make the answer very short. 27.82. What is the difference between the Electricity production(% of total) of Europe(developing only) in 2001 and the Electricity production(% of total) of Vietnam in 2005?
Offer a very short reply. 9.21. What is the difference between the Electricity production(% of total) of OECD members in 2001 and the Electricity production(% of total) of Uzbekistan in 2005?
Provide a succinct answer. 34.15. What is the difference between the Electricity production(% of total) in OECD members in 2001 and the Electricity production(% of total) in Vietnam in 2005?
Offer a terse response. 15.54. What is the difference between the Electricity production(% of total) of Uzbekistan in 2001 and the Electricity production(% of total) of Vietnam in 2005?
Make the answer very short. -18.61. What is the difference between the Electricity production(% of total) in Europe(developing only) in 2002 and the Electricity production(% of total) in OECD members in 2003?
Provide a succinct answer. -8.3. What is the difference between the Electricity production(% of total) in Europe(developing only) in 2002 and the Electricity production(% of total) in Uzbekistan in 2003?
Provide a short and direct response. 26.36. What is the difference between the Electricity production(% of total) in Europe(developing only) in 2002 and the Electricity production(% of total) in Vietnam in 2003?
Ensure brevity in your answer.  12.77. What is the difference between the Electricity production(% of total) in OECD members in 2002 and the Electricity production(% of total) in Uzbekistan in 2003?
Give a very brief answer. 33.97. What is the difference between the Electricity production(% of total) of OECD members in 2002 and the Electricity production(% of total) of Vietnam in 2003?
Provide a short and direct response. 20.37. What is the difference between the Electricity production(% of total) of Uzbekistan in 2002 and the Electricity production(% of total) of Vietnam in 2003?
Provide a succinct answer. -13.6. What is the difference between the Electricity production(% of total) in Europe(developing only) in 2002 and the Electricity production(% of total) in OECD members in 2004?
Ensure brevity in your answer.  -7.28. What is the difference between the Electricity production(% of total) in Europe(developing only) in 2002 and the Electricity production(% of total) in Uzbekistan in 2004?
Keep it short and to the point. 26.36. What is the difference between the Electricity production(% of total) in Europe(developing only) in 2002 and the Electricity production(% of total) in Vietnam in 2004?
Give a very brief answer. 14.93. What is the difference between the Electricity production(% of total) in OECD members in 2002 and the Electricity production(% of total) in Uzbekistan in 2004?
Your answer should be very brief. 33.96. What is the difference between the Electricity production(% of total) in OECD members in 2002 and the Electricity production(% of total) in Vietnam in 2004?
Ensure brevity in your answer.  22.53. What is the difference between the Electricity production(% of total) of Uzbekistan in 2002 and the Electricity production(% of total) of Vietnam in 2004?
Provide a short and direct response. -11.44. What is the difference between the Electricity production(% of total) of Europe(developing only) in 2002 and the Electricity production(% of total) of OECD members in 2005?
Offer a terse response. -7.15. What is the difference between the Electricity production(% of total) in Europe(developing only) in 2002 and the Electricity production(% of total) in Uzbekistan in 2005?
Give a very brief answer. 26.37. What is the difference between the Electricity production(% of total) in Europe(developing only) in 2002 and the Electricity production(% of total) in Vietnam in 2005?
Offer a very short reply. 7.76. What is the difference between the Electricity production(% of total) in OECD members in 2002 and the Electricity production(% of total) in Uzbekistan in 2005?
Make the answer very short. 33.97. What is the difference between the Electricity production(% of total) in OECD members in 2002 and the Electricity production(% of total) in Vietnam in 2005?
Offer a very short reply. 15.36. What is the difference between the Electricity production(% of total) of Uzbekistan in 2002 and the Electricity production(% of total) of Vietnam in 2005?
Ensure brevity in your answer.  -18.61. What is the difference between the Electricity production(% of total) in Europe(developing only) in 2003 and the Electricity production(% of total) in OECD members in 2004?
Provide a succinct answer. -6.66. What is the difference between the Electricity production(% of total) of Europe(developing only) in 2003 and the Electricity production(% of total) of Uzbekistan in 2004?
Make the answer very short. 26.99. What is the difference between the Electricity production(% of total) of Europe(developing only) in 2003 and the Electricity production(% of total) of Vietnam in 2004?
Offer a very short reply. 15.55. What is the difference between the Electricity production(% of total) in OECD members in 2003 and the Electricity production(% of total) in Uzbekistan in 2004?
Provide a short and direct response. 34.66. What is the difference between the Electricity production(% of total) of OECD members in 2003 and the Electricity production(% of total) of Vietnam in 2004?
Provide a succinct answer. 23.22. What is the difference between the Electricity production(% of total) of Uzbekistan in 2003 and the Electricity production(% of total) of Vietnam in 2004?
Your answer should be compact. -11.44. What is the difference between the Electricity production(% of total) in Europe(developing only) in 2003 and the Electricity production(% of total) in OECD members in 2005?
Provide a succinct answer. -6.52. What is the difference between the Electricity production(% of total) in Europe(developing only) in 2003 and the Electricity production(% of total) in Uzbekistan in 2005?
Offer a terse response. 26.99. What is the difference between the Electricity production(% of total) in Europe(developing only) in 2003 and the Electricity production(% of total) in Vietnam in 2005?
Your answer should be compact. 8.38. What is the difference between the Electricity production(% of total) in OECD members in 2003 and the Electricity production(% of total) in Uzbekistan in 2005?
Give a very brief answer. 34.66. What is the difference between the Electricity production(% of total) in OECD members in 2003 and the Electricity production(% of total) in Vietnam in 2005?
Offer a terse response. 16.06. What is the difference between the Electricity production(% of total) in Uzbekistan in 2003 and the Electricity production(% of total) in Vietnam in 2005?
Offer a terse response. -18.61. What is the difference between the Electricity production(% of total) of Europe(developing only) in 2004 and the Electricity production(% of total) of OECD members in 2005?
Offer a terse response. -8.24. What is the difference between the Electricity production(% of total) in Europe(developing only) in 2004 and the Electricity production(% of total) in Uzbekistan in 2005?
Make the answer very short. 25.28. What is the difference between the Electricity production(% of total) of Europe(developing only) in 2004 and the Electricity production(% of total) of Vietnam in 2005?
Keep it short and to the point. 6.67. What is the difference between the Electricity production(% of total) in OECD members in 2004 and the Electricity production(% of total) in Uzbekistan in 2005?
Your answer should be very brief. 33.65. What is the difference between the Electricity production(% of total) in OECD members in 2004 and the Electricity production(% of total) in Vietnam in 2005?
Your response must be concise. 15.04. What is the difference between the Electricity production(% of total) of Uzbekistan in 2004 and the Electricity production(% of total) of Vietnam in 2005?
Provide a short and direct response. -18.6. What is the average Electricity production(% of total) of Europe(developing only) per year?
Offer a terse response. 30.45. What is the average Electricity production(% of total) in OECD members per year?
Your response must be concise. 38.23. What is the average Electricity production(% of total) in Uzbekistan per year?
Ensure brevity in your answer.  4.09. What is the average Electricity production(% of total) of Vietnam per year?
Provide a succinct answer. 15.03. In the year 1998, what is the difference between the Electricity production(% of total) in Europe(developing only) and Electricity production(% of total) in OECD members?
Your answer should be very brief. -8.39. In the year 1998, what is the difference between the Electricity production(% of total) in Europe(developing only) and Electricity production(% of total) in Uzbekistan?
Give a very brief answer. 26.19. In the year 1998, what is the difference between the Electricity production(% of total) in Europe(developing only) and Electricity production(% of total) in Vietnam?
Offer a terse response. 14.23. In the year 1998, what is the difference between the Electricity production(% of total) of OECD members and Electricity production(% of total) of Uzbekistan?
Your answer should be compact. 34.58. In the year 1998, what is the difference between the Electricity production(% of total) in OECD members and Electricity production(% of total) in Vietnam?
Provide a succinct answer. 22.62. In the year 1998, what is the difference between the Electricity production(% of total) in Uzbekistan and Electricity production(% of total) in Vietnam?
Ensure brevity in your answer.  -11.96. In the year 1999, what is the difference between the Electricity production(% of total) in Europe(developing only) and Electricity production(% of total) in OECD members?
Your answer should be very brief. -8.34. In the year 1999, what is the difference between the Electricity production(% of total) of Europe(developing only) and Electricity production(% of total) of Uzbekistan?
Make the answer very short. 25.58. In the year 1999, what is the difference between the Electricity production(% of total) of Europe(developing only) and Electricity production(% of total) of Vietnam?
Keep it short and to the point. 17.3. In the year 1999, what is the difference between the Electricity production(% of total) of OECD members and Electricity production(% of total) of Uzbekistan?
Keep it short and to the point. 33.92. In the year 1999, what is the difference between the Electricity production(% of total) in OECD members and Electricity production(% of total) in Vietnam?
Make the answer very short. 25.63. In the year 1999, what is the difference between the Electricity production(% of total) in Uzbekistan and Electricity production(% of total) in Vietnam?
Keep it short and to the point. -8.29. In the year 2000, what is the difference between the Electricity production(% of total) in Europe(developing only) and Electricity production(% of total) in OECD members?
Provide a succinct answer. -8.19. In the year 2000, what is the difference between the Electricity production(% of total) of Europe(developing only) and Electricity production(% of total) of Uzbekistan?
Make the answer very short. 26.53. In the year 2000, what is the difference between the Electricity production(% of total) in Europe(developing only) and Electricity production(% of total) in Vietnam?
Provide a succinct answer. 18.81. In the year 2000, what is the difference between the Electricity production(% of total) of OECD members and Electricity production(% of total) of Uzbekistan?
Ensure brevity in your answer.  34.71. In the year 2000, what is the difference between the Electricity production(% of total) in OECD members and Electricity production(% of total) in Vietnam?
Your answer should be compact. 27. In the year 2000, what is the difference between the Electricity production(% of total) in Uzbekistan and Electricity production(% of total) in Vietnam?
Offer a terse response. -7.72. In the year 2001, what is the difference between the Electricity production(% of total) of Europe(developing only) and Electricity production(% of total) of OECD members?
Your response must be concise. -6.33. In the year 2001, what is the difference between the Electricity production(% of total) in Europe(developing only) and Electricity production(% of total) in Uzbekistan?
Ensure brevity in your answer.  27.82. In the year 2001, what is the difference between the Electricity production(% of total) of Europe(developing only) and Electricity production(% of total) of Vietnam?
Make the answer very short. 21.39. In the year 2001, what is the difference between the Electricity production(% of total) in OECD members and Electricity production(% of total) in Uzbekistan?
Ensure brevity in your answer.  34.15. In the year 2001, what is the difference between the Electricity production(% of total) of OECD members and Electricity production(% of total) of Vietnam?
Offer a very short reply. 27.72. In the year 2001, what is the difference between the Electricity production(% of total) of Uzbekistan and Electricity production(% of total) of Vietnam?
Provide a short and direct response. -6.43. In the year 2002, what is the difference between the Electricity production(% of total) of Europe(developing only) and Electricity production(% of total) of OECD members?
Ensure brevity in your answer.  -7.6. In the year 2002, what is the difference between the Electricity production(% of total) in Europe(developing only) and Electricity production(% of total) in Uzbekistan?
Your answer should be compact. 26.36. In the year 2002, what is the difference between the Electricity production(% of total) in Europe(developing only) and Electricity production(% of total) in Vietnam?
Your response must be concise. 16.82. In the year 2002, what is the difference between the Electricity production(% of total) in OECD members and Electricity production(% of total) in Uzbekistan?
Keep it short and to the point. 33.97. In the year 2002, what is the difference between the Electricity production(% of total) in OECD members and Electricity production(% of total) in Vietnam?
Offer a very short reply. 24.42. In the year 2002, what is the difference between the Electricity production(% of total) in Uzbekistan and Electricity production(% of total) in Vietnam?
Ensure brevity in your answer.  -9.54. In the year 2003, what is the difference between the Electricity production(% of total) of Europe(developing only) and Electricity production(% of total) of OECD members?
Your response must be concise. -7.67. In the year 2003, what is the difference between the Electricity production(% of total) of Europe(developing only) and Electricity production(% of total) of Uzbekistan?
Your answer should be very brief. 26.99. In the year 2003, what is the difference between the Electricity production(% of total) of Europe(developing only) and Electricity production(% of total) of Vietnam?
Provide a short and direct response. 13.39. In the year 2003, what is the difference between the Electricity production(% of total) of OECD members and Electricity production(% of total) of Uzbekistan?
Ensure brevity in your answer.  34.66. In the year 2003, what is the difference between the Electricity production(% of total) of OECD members and Electricity production(% of total) of Vietnam?
Offer a very short reply. 21.06. In the year 2003, what is the difference between the Electricity production(% of total) in Uzbekistan and Electricity production(% of total) in Vietnam?
Provide a succinct answer. -13.6. In the year 2004, what is the difference between the Electricity production(% of total) in Europe(developing only) and Electricity production(% of total) in OECD members?
Give a very brief answer. -8.37. In the year 2004, what is the difference between the Electricity production(% of total) in Europe(developing only) and Electricity production(% of total) in Uzbekistan?
Offer a very short reply. 25.27. In the year 2004, what is the difference between the Electricity production(% of total) of Europe(developing only) and Electricity production(% of total) of Vietnam?
Give a very brief answer. 13.84. In the year 2004, what is the difference between the Electricity production(% of total) of OECD members and Electricity production(% of total) of Uzbekistan?
Offer a terse response. 33.64. In the year 2004, what is the difference between the Electricity production(% of total) in OECD members and Electricity production(% of total) in Vietnam?
Offer a very short reply. 22.21. In the year 2004, what is the difference between the Electricity production(% of total) in Uzbekistan and Electricity production(% of total) in Vietnam?
Offer a very short reply. -11.44. In the year 2005, what is the difference between the Electricity production(% of total) in Europe(developing only) and Electricity production(% of total) in OECD members?
Your response must be concise. -7.38. In the year 2005, what is the difference between the Electricity production(% of total) in Europe(developing only) and Electricity production(% of total) in Uzbekistan?
Keep it short and to the point. 26.14. In the year 2005, what is the difference between the Electricity production(% of total) in Europe(developing only) and Electricity production(% of total) in Vietnam?
Offer a terse response. 7.53. In the year 2005, what is the difference between the Electricity production(% of total) in OECD members and Electricity production(% of total) in Uzbekistan?
Provide a succinct answer. 33.51. In the year 2005, what is the difference between the Electricity production(% of total) of OECD members and Electricity production(% of total) of Vietnam?
Give a very brief answer. 14.9. In the year 2005, what is the difference between the Electricity production(% of total) in Uzbekistan and Electricity production(% of total) in Vietnam?
Provide a succinct answer. -18.61. What is the ratio of the Electricity production(% of total) in Europe(developing only) in 1998 to that in 1999?
Ensure brevity in your answer.  1.02. What is the ratio of the Electricity production(% of total) in OECD members in 1998 to that in 1999?
Your answer should be very brief. 1.02. What is the ratio of the Electricity production(% of total) of Uzbekistan in 1998 to that in 1999?
Offer a terse response. 1. What is the ratio of the Electricity production(% of total) in Vietnam in 1998 to that in 1999?
Make the answer very short. 1.3. What is the ratio of the Electricity production(% of total) of Europe(developing only) in 1998 to that in 2000?
Provide a short and direct response. 0.99. What is the ratio of the Electricity production(% of total) of Vietnam in 1998 to that in 2000?
Keep it short and to the point. 1.36. What is the ratio of the Electricity production(% of total) of Europe(developing only) in 1998 to that in 2001?
Keep it short and to the point. 0.95. What is the ratio of the Electricity production(% of total) in OECD members in 1998 to that in 2001?
Provide a short and direct response. 1.01. What is the ratio of the Electricity production(% of total) in Uzbekistan in 1998 to that in 2001?
Offer a terse response. 1. What is the ratio of the Electricity production(% of total) in Vietnam in 1998 to that in 2001?
Provide a succinct answer. 1.53. What is the ratio of the Electricity production(% of total) of Europe(developing only) in 1998 to that in 2002?
Your response must be concise. 0.99. What is the ratio of the Electricity production(% of total) in OECD members in 1998 to that in 2002?
Keep it short and to the point. 1.02. What is the ratio of the Electricity production(% of total) in Vietnam in 1998 to that in 2002?
Ensure brevity in your answer.  1.18. What is the ratio of the Electricity production(% of total) in Europe(developing only) in 1998 to that in 2003?
Keep it short and to the point. 0.97. What is the ratio of the Electricity production(% of total) of Vietnam in 1998 to that in 2003?
Give a very brief answer. 0.91. What is the ratio of the Electricity production(% of total) of Europe(developing only) in 1998 to that in 2004?
Make the answer very short. 1.03. What is the ratio of the Electricity production(% of total) in OECD members in 1998 to that in 2004?
Your answer should be very brief. 1.02. What is the ratio of the Electricity production(% of total) of Uzbekistan in 1998 to that in 2004?
Offer a very short reply. 1. What is the ratio of the Electricity production(% of total) in Vietnam in 1998 to that in 2004?
Offer a terse response. 1.03. What is the ratio of the Electricity production(% of total) of OECD members in 1998 to that in 2005?
Your answer should be compact. 1.03. What is the ratio of the Electricity production(% of total) of Uzbekistan in 1998 to that in 2005?
Offer a very short reply. 1. What is the ratio of the Electricity production(% of total) of Vietnam in 1998 to that in 2005?
Your response must be concise. 0.71. What is the ratio of the Electricity production(% of total) in Europe(developing only) in 1999 to that in 2000?
Make the answer very short. 0.97. What is the ratio of the Electricity production(% of total) in OECD members in 1999 to that in 2000?
Provide a succinct answer. 0.98. What is the ratio of the Electricity production(% of total) in Vietnam in 1999 to that in 2000?
Provide a short and direct response. 1.05. What is the ratio of the Electricity production(% of total) in Vietnam in 1999 to that in 2001?
Offer a terse response. 1.18. What is the ratio of the Electricity production(% of total) in Europe(developing only) in 1999 to that in 2002?
Offer a very short reply. 0.97. What is the ratio of the Electricity production(% of total) of OECD members in 1999 to that in 2002?
Offer a terse response. 1. What is the ratio of the Electricity production(% of total) of Uzbekistan in 1999 to that in 2002?
Provide a short and direct response. 1. What is the ratio of the Electricity production(% of total) in Vietnam in 1999 to that in 2002?
Make the answer very short. 0.91. What is the ratio of the Electricity production(% of total) in Europe(developing only) in 1999 to that in 2003?
Ensure brevity in your answer.  0.95. What is the ratio of the Electricity production(% of total) of OECD members in 1999 to that in 2003?
Give a very brief answer. 0.98. What is the ratio of the Electricity production(% of total) in Vietnam in 1999 to that in 2003?
Provide a short and direct response. 0.7. What is the ratio of the Electricity production(% of total) of Europe(developing only) in 1999 to that in 2004?
Provide a short and direct response. 1.01. What is the ratio of the Electricity production(% of total) in OECD members in 1999 to that in 2004?
Your answer should be very brief. 1.01. What is the ratio of the Electricity production(% of total) of Uzbekistan in 1999 to that in 2004?
Your answer should be very brief. 1. What is the ratio of the Electricity production(% of total) of Vietnam in 1999 to that in 2004?
Keep it short and to the point. 0.8. What is the ratio of the Electricity production(% of total) of Europe(developing only) in 1999 to that in 2005?
Offer a terse response. 0.98. What is the ratio of the Electricity production(% of total) in OECD members in 1999 to that in 2005?
Keep it short and to the point. 1.01. What is the ratio of the Electricity production(% of total) in Uzbekistan in 1999 to that in 2005?
Provide a succinct answer. 1. What is the ratio of the Electricity production(% of total) in Vietnam in 1999 to that in 2005?
Provide a succinct answer. 0.55. What is the ratio of the Electricity production(% of total) in Europe(developing only) in 2000 to that in 2001?
Provide a succinct answer. 0.96. What is the ratio of the Electricity production(% of total) of OECD members in 2000 to that in 2001?
Provide a short and direct response. 1.01. What is the ratio of the Electricity production(% of total) of Uzbekistan in 2000 to that in 2001?
Keep it short and to the point. 1. What is the ratio of the Electricity production(% of total) in Vietnam in 2000 to that in 2001?
Your answer should be very brief. 1.12. What is the ratio of the Electricity production(% of total) in Europe(developing only) in 2000 to that in 2002?
Offer a very short reply. 1.01. What is the ratio of the Electricity production(% of total) of OECD members in 2000 to that in 2002?
Give a very brief answer. 1.02. What is the ratio of the Electricity production(% of total) in Uzbekistan in 2000 to that in 2002?
Your answer should be very brief. 1. What is the ratio of the Electricity production(% of total) of Vietnam in 2000 to that in 2002?
Your answer should be compact. 0.87. What is the ratio of the Electricity production(% of total) of Europe(developing only) in 2000 to that in 2003?
Your answer should be compact. 0.99. What is the ratio of the Electricity production(% of total) in OECD members in 2000 to that in 2003?
Provide a succinct answer. 1. What is the ratio of the Electricity production(% of total) of Uzbekistan in 2000 to that in 2003?
Keep it short and to the point. 1. What is the ratio of the Electricity production(% of total) of Vietnam in 2000 to that in 2003?
Offer a terse response. 0.67. What is the ratio of the Electricity production(% of total) in Europe(developing only) in 2000 to that in 2004?
Offer a very short reply. 1.04. What is the ratio of the Electricity production(% of total) of OECD members in 2000 to that in 2004?
Make the answer very short. 1.03. What is the ratio of the Electricity production(% of total) in Uzbekistan in 2000 to that in 2004?
Ensure brevity in your answer.  1. What is the ratio of the Electricity production(% of total) in Vietnam in 2000 to that in 2004?
Offer a terse response. 0.76. What is the ratio of the Electricity production(% of total) of OECD members in 2000 to that in 2005?
Keep it short and to the point. 1.03. What is the ratio of the Electricity production(% of total) of Uzbekistan in 2000 to that in 2005?
Ensure brevity in your answer.  1. What is the ratio of the Electricity production(% of total) of Vietnam in 2000 to that in 2005?
Keep it short and to the point. 0.52. What is the ratio of the Electricity production(% of total) in Europe(developing only) in 2001 to that in 2002?
Provide a succinct answer. 1.05. What is the ratio of the Electricity production(% of total) of OECD members in 2001 to that in 2002?
Ensure brevity in your answer.  1. What is the ratio of the Electricity production(% of total) in Vietnam in 2001 to that in 2002?
Your answer should be compact. 0.77. What is the ratio of the Electricity production(% of total) in Europe(developing only) in 2001 to that in 2003?
Provide a short and direct response. 1.03. What is the ratio of the Electricity production(% of total) in OECD members in 2001 to that in 2003?
Keep it short and to the point. 0.99. What is the ratio of the Electricity production(% of total) of Uzbekistan in 2001 to that in 2003?
Keep it short and to the point. 1. What is the ratio of the Electricity production(% of total) of Vietnam in 2001 to that in 2003?
Ensure brevity in your answer.  0.59. What is the ratio of the Electricity production(% of total) of Europe(developing only) in 2001 to that in 2004?
Keep it short and to the point. 1.09. What is the ratio of the Electricity production(% of total) in OECD members in 2001 to that in 2004?
Keep it short and to the point. 1.01. What is the ratio of the Electricity production(% of total) in Uzbekistan in 2001 to that in 2004?
Provide a short and direct response. 1. What is the ratio of the Electricity production(% of total) in Vietnam in 2001 to that in 2004?
Make the answer very short. 0.68. What is the ratio of the Electricity production(% of total) in Europe(developing only) in 2001 to that in 2005?
Offer a terse response. 1.06. What is the ratio of the Electricity production(% of total) in Uzbekistan in 2001 to that in 2005?
Make the answer very short. 1. What is the ratio of the Electricity production(% of total) in Vietnam in 2001 to that in 2005?
Offer a terse response. 0.46. What is the ratio of the Electricity production(% of total) in Europe(developing only) in 2002 to that in 2003?
Your answer should be compact. 0.98. What is the ratio of the Electricity production(% of total) of OECD members in 2002 to that in 2003?
Offer a terse response. 0.98. What is the ratio of the Electricity production(% of total) in Uzbekistan in 2002 to that in 2003?
Give a very brief answer. 1. What is the ratio of the Electricity production(% of total) of Vietnam in 2002 to that in 2003?
Your answer should be very brief. 0.77. What is the ratio of the Electricity production(% of total) of Europe(developing only) in 2002 to that in 2004?
Provide a succinct answer. 1.04. What is the ratio of the Electricity production(% of total) in OECD members in 2002 to that in 2004?
Keep it short and to the point. 1.01. What is the ratio of the Electricity production(% of total) in Uzbekistan in 2002 to that in 2004?
Offer a terse response. 1. What is the ratio of the Electricity production(% of total) of Vietnam in 2002 to that in 2004?
Provide a succinct answer. 0.88. What is the ratio of the Electricity production(% of total) of Europe(developing only) in 2002 to that in 2005?
Ensure brevity in your answer.  1.01. What is the ratio of the Electricity production(% of total) in OECD members in 2002 to that in 2005?
Your answer should be compact. 1.01. What is the ratio of the Electricity production(% of total) in Uzbekistan in 2002 to that in 2005?
Offer a very short reply. 1. What is the ratio of the Electricity production(% of total) in Vietnam in 2002 to that in 2005?
Your answer should be very brief. 0.6. What is the ratio of the Electricity production(% of total) of Europe(developing only) in 2003 to that in 2004?
Make the answer very short. 1.06. What is the ratio of the Electricity production(% of total) of OECD members in 2003 to that in 2004?
Make the answer very short. 1.03. What is the ratio of the Electricity production(% of total) in Vietnam in 2003 to that in 2004?
Keep it short and to the point. 1.14. What is the ratio of the Electricity production(% of total) of Europe(developing only) in 2003 to that in 2005?
Give a very brief answer. 1.03. What is the ratio of the Electricity production(% of total) in OECD members in 2003 to that in 2005?
Your answer should be compact. 1.03. What is the ratio of the Electricity production(% of total) of Uzbekistan in 2003 to that in 2005?
Your response must be concise. 1. What is the ratio of the Electricity production(% of total) in Vietnam in 2003 to that in 2005?
Provide a short and direct response. 0.78. What is the ratio of the Electricity production(% of total) of Europe(developing only) in 2004 to that in 2005?
Your answer should be compact. 0.97. What is the ratio of the Electricity production(% of total) in Uzbekistan in 2004 to that in 2005?
Keep it short and to the point. 1. What is the ratio of the Electricity production(% of total) of Vietnam in 2004 to that in 2005?
Your answer should be very brief. 0.68. What is the difference between the highest and the second highest Electricity production(% of total) of Europe(developing only)?
Offer a terse response. 0.83. What is the difference between the highest and the second highest Electricity production(% of total) of OECD members?
Make the answer very short. 0.05. What is the difference between the highest and the second highest Electricity production(% of total) in Vietnam?
Make the answer very short. 5.01. What is the difference between the highest and the lowest Electricity production(% of total) of Europe(developing only)?
Keep it short and to the point. 2.54. What is the difference between the highest and the lowest Electricity production(% of total) in OECD members?
Your answer should be compact. 1.2. What is the difference between the highest and the lowest Electricity production(% of total) of Uzbekistan?
Provide a succinct answer. 0. What is the difference between the highest and the lowest Electricity production(% of total) of Vietnam?
Keep it short and to the point. 12.18. 